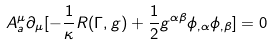<formula> <loc_0><loc_0><loc_500><loc_500>A _ { a } ^ { \mu } \partial _ { \mu } [ - \frac { 1 } { \kappa } R ( \Gamma , g ) + \frac { 1 } { 2 } g ^ { \alpha \beta } \phi _ { , \alpha } \phi _ { , \beta } ] = 0</formula> 